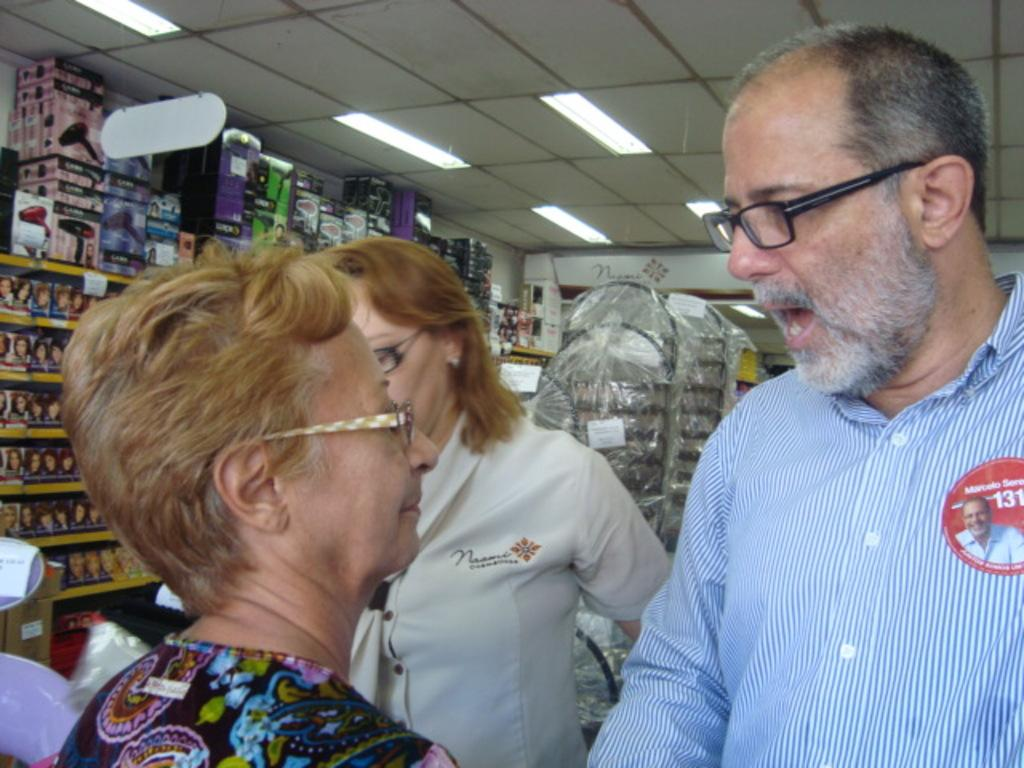How many people are in the image? There are three persons in the image. What are the persons wearing that is common among them? The persons are wearing spectacles. What can be seen in the background of the image? There is a rack, boxes, and lights in the background of the image. From where was the image taken? The image is taken from a roof or elevated position. What type of collar can be seen on the person in the middle of the image? There is no collar visible on any of the persons in the image. What kind of lace is draped over the rack in the background? There is no lace present in the image; only a rack, boxes, and lights are visible in the background. 